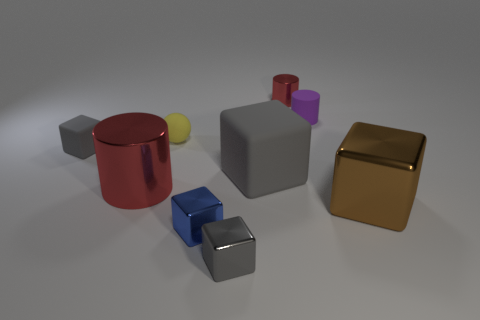Subtract all purple cylinders. How many gray blocks are left? 3 Subtract all blue blocks. How many blocks are left? 4 Subtract all green blocks. Subtract all green cylinders. How many blocks are left? 5 Add 1 red objects. How many objects exist? 10 Subtract all spheres. How many objects are left? 8 Subtract 1 brown cubes. How many objects are left? 8 Subtract all blue shiny cylinders. Subtract all metallic blocks. How many objects are left? 6 Add 7 tiny balls. How many tiny balls are left? 8 Add 3 large green metal cylinders. How many large green metal cylinders exist? 3 